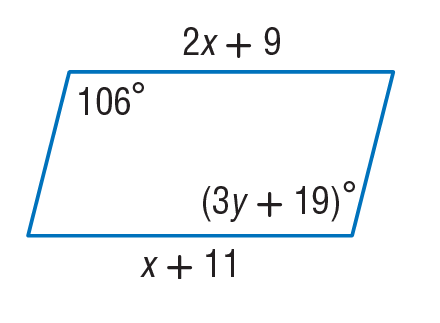Question: Find x so that the quadrilateral is a parallelogram.
Choices:
A. 2
B. 4
C. 13
D. 66
Answer with the letter. Answer: A 